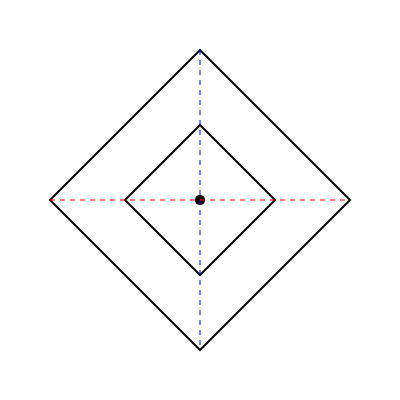Given the geometric pattern above, identify the number of distinct symmetry operations (excluding the identity) that leave the pattern invariant. Express your answer using the concept of the dihedral group $D_n$, where $n$ represents the order of rotational symmetry. To solve this problem, we need to analyze the symmetries of the given pattern:

1. Rotational symmetry:
   - The pattern has 4-fold rotational symmetry (90°, 180°, 270°, 360°).
   - This contributes 3 distinct symmetry operations (excluding the identity).

2. Reflection symmetry:
   - There are two lines of reflection: horizontal (red dashed line) and vertical (blue dashed line).
   - The diagonals of the squares also serve as lines of reflection.
   - This contributes 4 distinct symmetry operations.

3. Dihedral group:
   - The symmetries of this pattern form the dihedral group $D_4$.
   - The order of $D_4$ is given by $|D_4| = 2n = 2 * 4 = 8$.
   - This includes the identity element, so we subtract 1 to get the number of distinct symmetry operations.

Therefore, the total number of distinct symmetry operations (excluding the identity) is:
$|D_4| - 1 = 8 - 1 = 7$

In terms of the dihedral group $D_n$, we can express this as $2n - 1$, where $n = 4$ in this case.
Answer: $2n - 1$, where $n = 4$ 